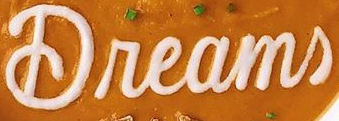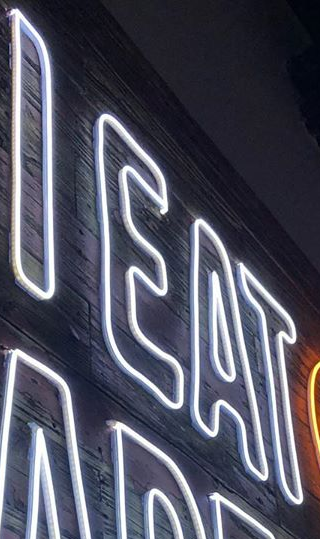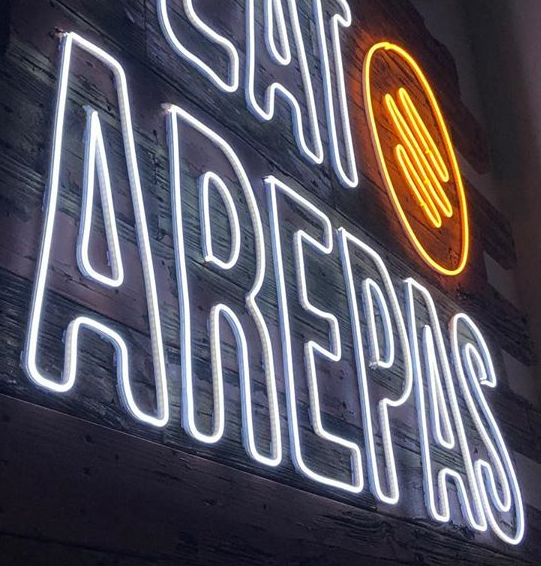Identify the words shown in these images in order, separated by a semicolon. Dreams; IEAT; AREPAS 